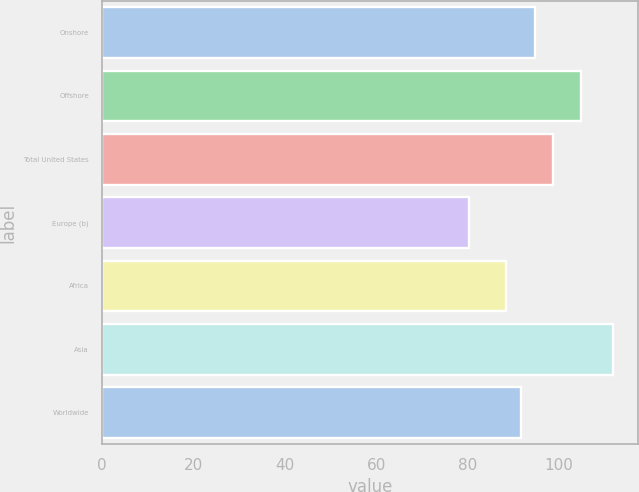Convert chart to OTSL. <chart><loc_0><loc_0><loc_500><loc_500><bar_chart><fcel>Onshore<fcel>Offshore<fcel>Total United States<fcel>Europe (b)<fcel>Africa<fcel>Asia<fcel>Worldwide<nl><fcel>94.76<fcel>104.83<fcel>98.56<fcel>80.18<fcel>88.46<fcel>111.71<fcel>91.61<nl></chart> 